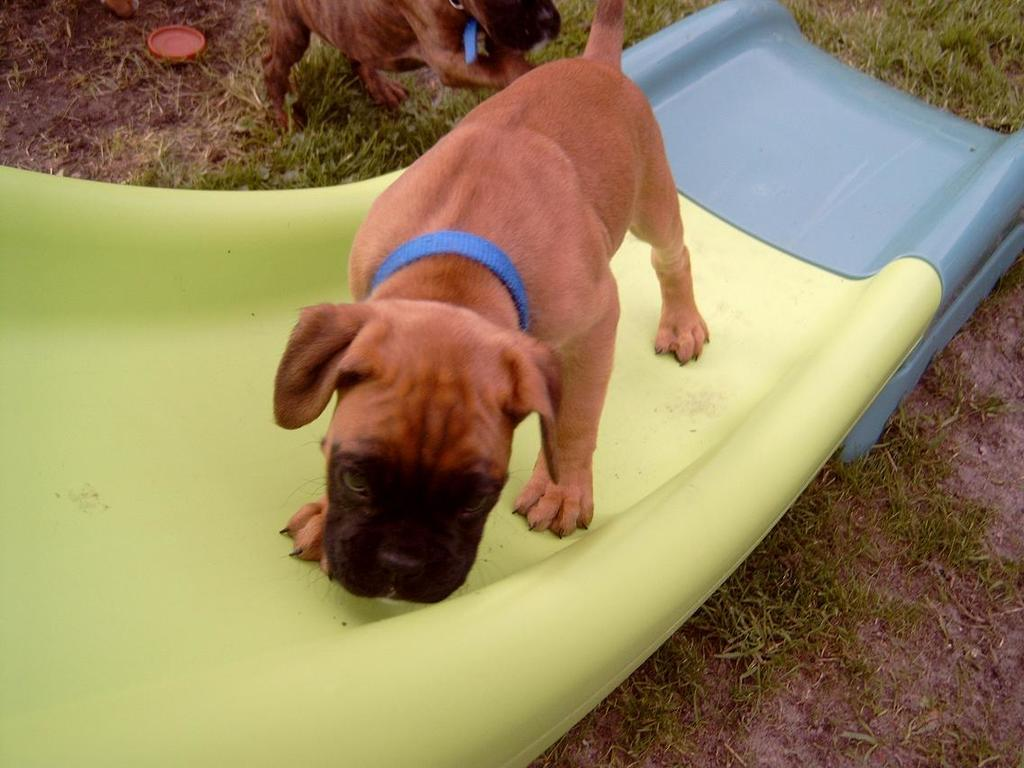What is the main subject of the image? The main subject of the image is a dog on a slide. Can you describe the position of the dog in the image? The dog is on a slide in the image. What else can be seen in the image besides the dog on the slide? There is an object at the top of the image and another dog on the grass. How does the dog on the slide express its pain in the image? There is no indication of pain in the image; the dog on the slide appears to be enjoying itself. Can you tell me how many yaks are present in the image? There are no yaks present in the image. 